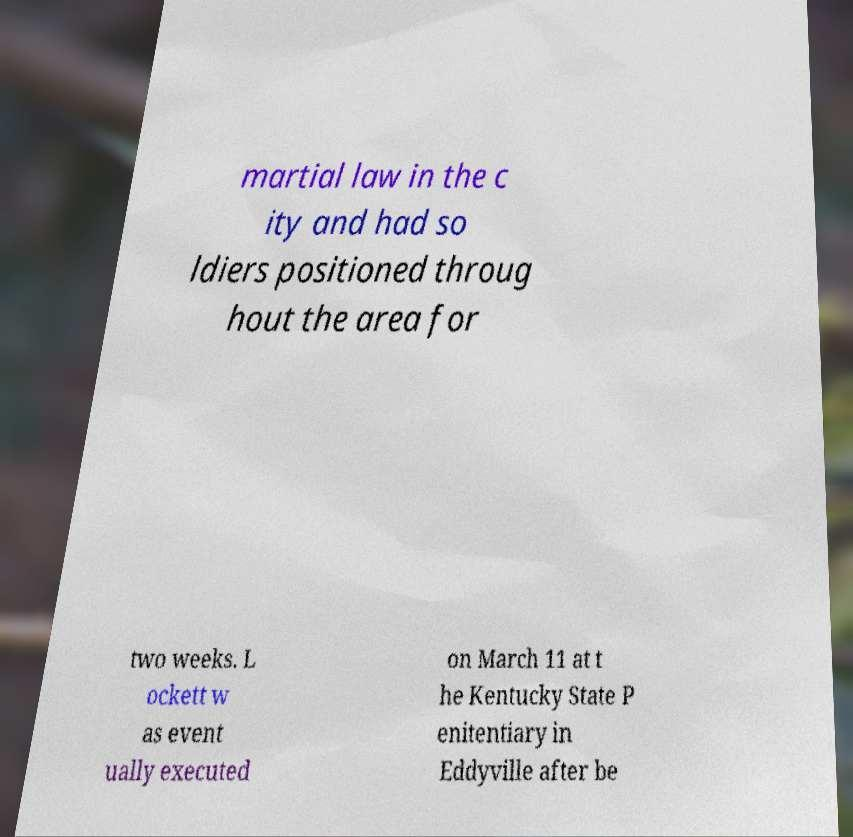Could you extract and type out the text from this image? martial law in the c ity and had so ldiers positioned throug hout the area for two weeks. L ockett w as event ually executed on March 11 at t he Kentucky State P enitentiary in Eddyville after be 